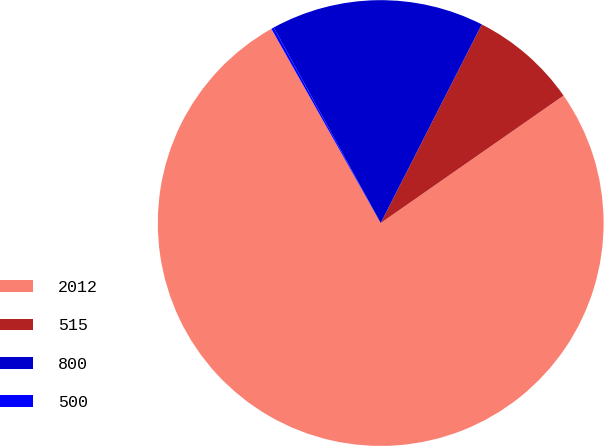Convert chart to OTSL. <chart><loc_0><loc_0><loc_500><loc_500><pie_chart><fcel>2012<fcel>515<fcel>800<fcel>500<nl><fcel>76.53%<fcel>7.82%<fcel>15.46%<fcel>0.19%<nl></chart> 